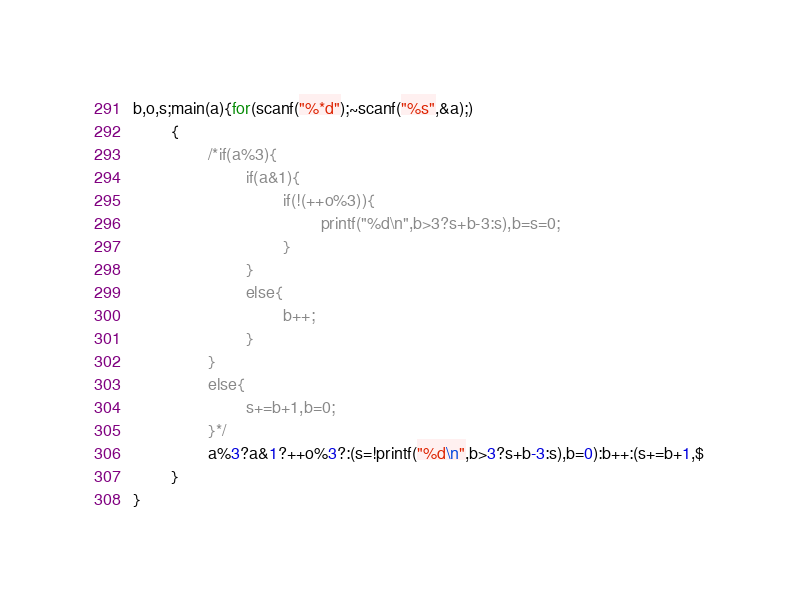Convert code to text. <code><loc_0><loc_0><loc_500><loc_500><_C_>b,o,s;main(a){for(scanf("%*d");~scanf("%s",&a);)
        {
                /*if(a%3){
                        if(a&1){
                                if(!(++o%3)){
                                        printf("%d\n",b>3?s+b-3:s),b=s=0;
                                }
                        }
                        else{
                                b++;
                        }
                }
                else{
                        s+=b+1,b=0;
                }*/
                a%3?a&1?++o%3?:(s=!printf("%d\n",b>3?s+b-3:s),b=0):b++:(s+=b+1,$
        }
}</code> 